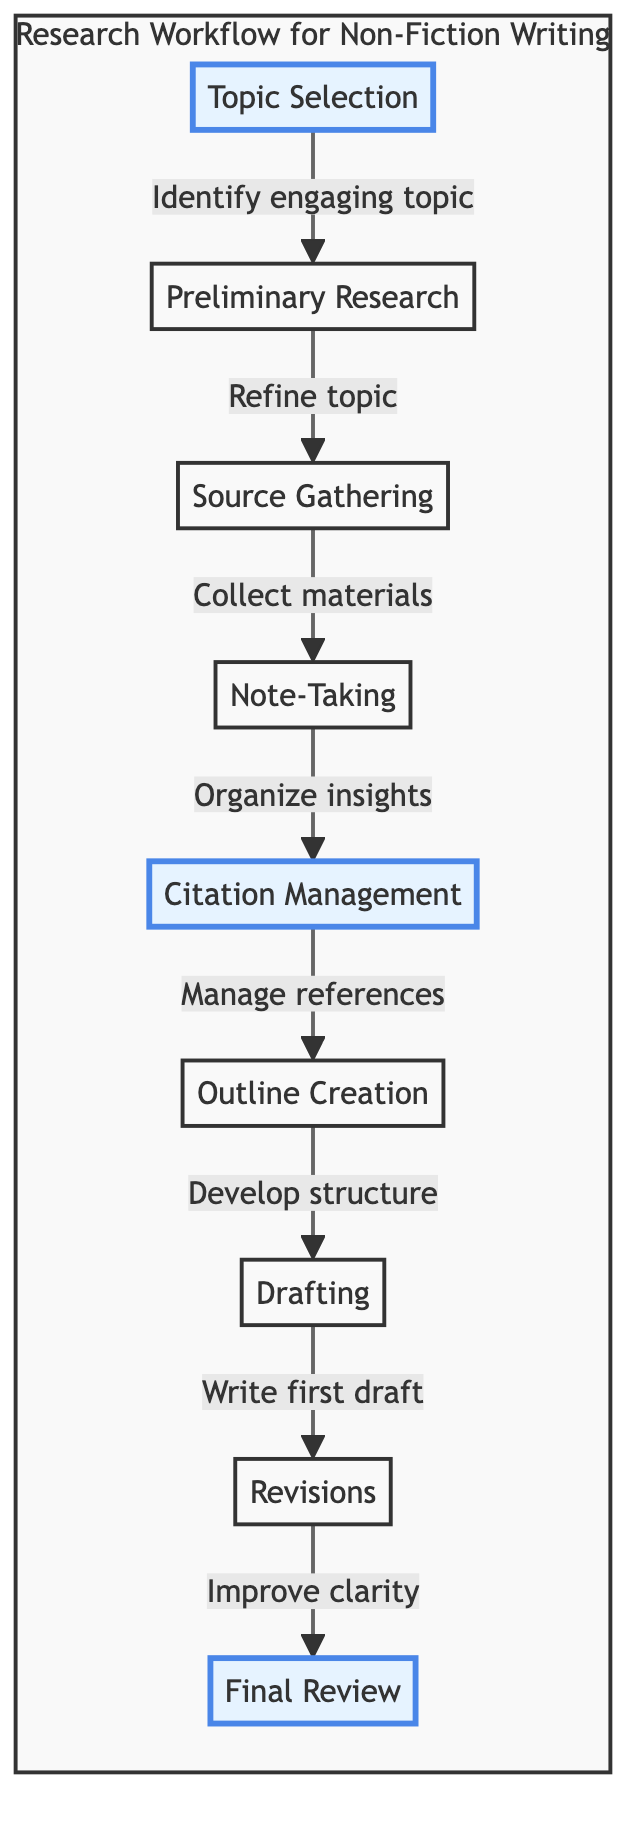What is the first step in the research workflow? The diagram specifies that the first step is Topic Selection, as indicated at the beginning of the flow.
Answer: Topic Selection How many main steps are illustrated in the workflow? The diagram presents a total of nine steps in the workflow, each clearly labeled.
Answer: 9 What is the purpose of the Source Gathering step? The diagram describes this step as collecting books, articles, and other relevant materials, which is essential for further research.
Answer: Collect materials Which step follows Citation Management? According to the flow chart, Outline Creation is the next step that follows Citation Management in the research workflow.
Answer: Outline Creation What are the two emphasized steps in the flowchart? The diagram highlights Topic Selection and Citation Management as the emphasized steps, indicated by different styles on these nodes.
Answer: Topic Selection, Citation Management What is the relationship between Note-Taking and Citation Management? The diagram shows that Note-Taking leads to Citation Management, indicating that organizing notes feeds into managing references.
Answer: Note-Taking leads to Citation Management Which step directly proceeds Drafting? The diagram illustrates that Outline Creation directly precedes Drafting in the sequence of steps for writing.
Answer: Outline Creation What is the final stage of the workflow? The last step in the research workflow is Final Review, marking the end of the process as represented in the diagram.
Answer: Final Review What does the Revision step focus on? The diagram specifies that the Revisions step aims to improve clarity, coherence, and accuracy in the drafting process.
Answer: Improve clarity 